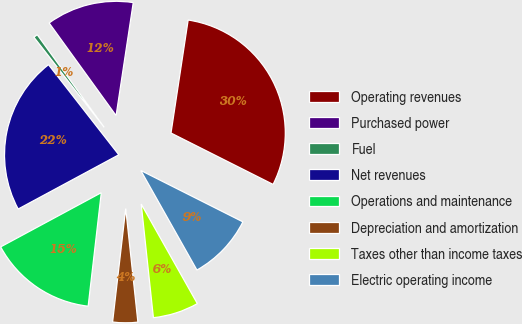Convert chart to OTSL. <chart><loc_0><loc_0><loc_500><loc_500><pie_chart><fcel>Operating revenues<fcel>Purchased power<fcel>Fuel<fcel>Net revenues<fcel>Operations and maintenance<fcel>Depreciation and amortization<fcel>Taxes other than income taxes<fcel>Electric operating income<nl><fcel>30.02%<fcel>12.36%<fcel>0.58%<fcel>22.32%<fcel>15.3%<fcel>3.53%<fcel>6.47%<fcel>9.41%<nl></chart> 